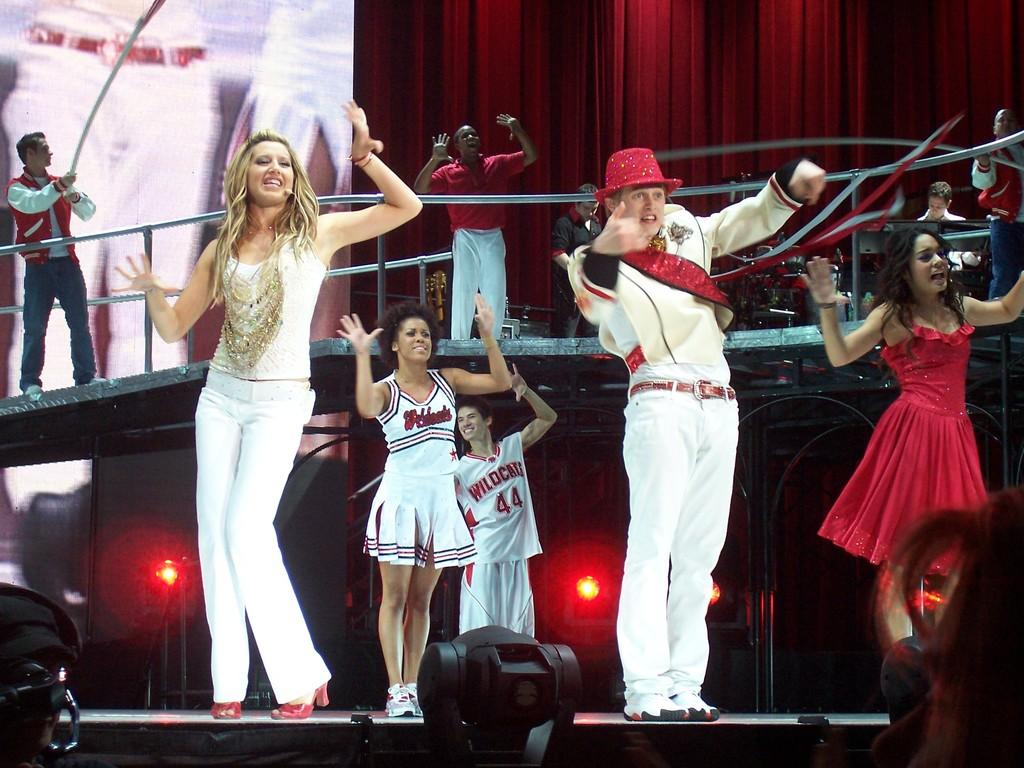How many people are present in the image? There are people in the image, but the exact number is not specified. What can be seen in the background of the image? There is a railing, a screen, a red curtain, and focusing lights in the image. What are the people doing in the image? Some people are dancing on a stage in the image. What objects are present in the image? There are musical instruments and other objects in the image. What is the price of the insurance policy for the musical instruments in the image? There is no mention of insurance or prices in the image, so it is not possible to answer that question. 